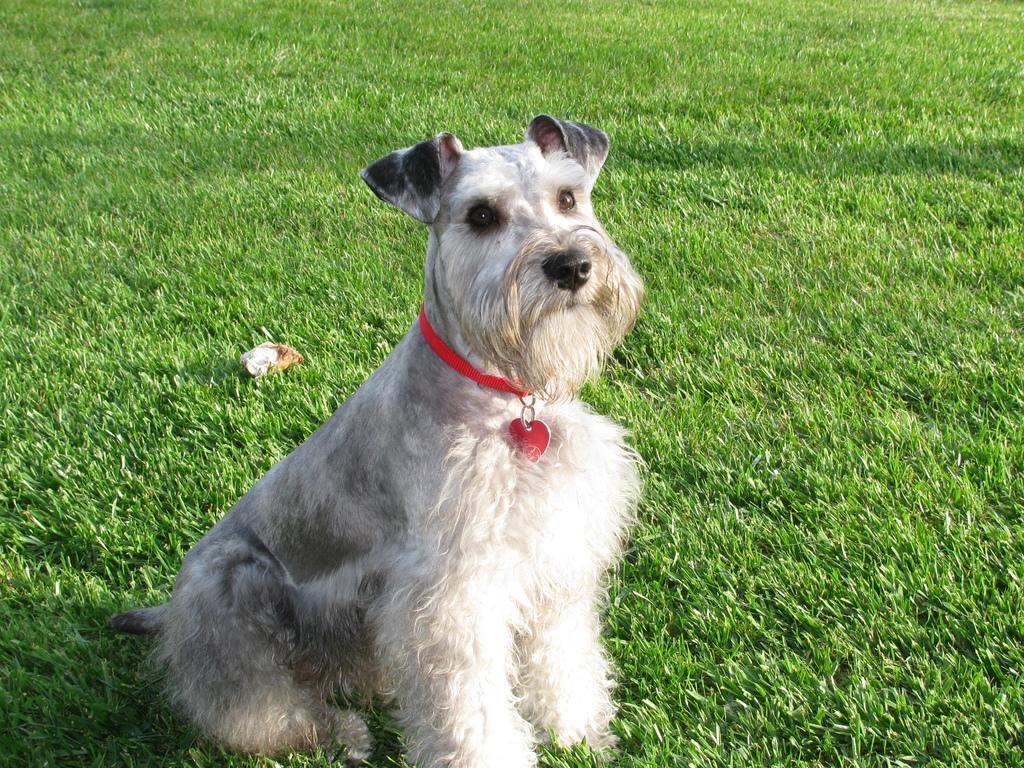In one or two sentences, can you explain what this image depicts? In this image we can see one dog with red belt sitting on the ground, heart shaped red key chain attached to the dog belt, one object on the ground and in the background some grass on the ground. 